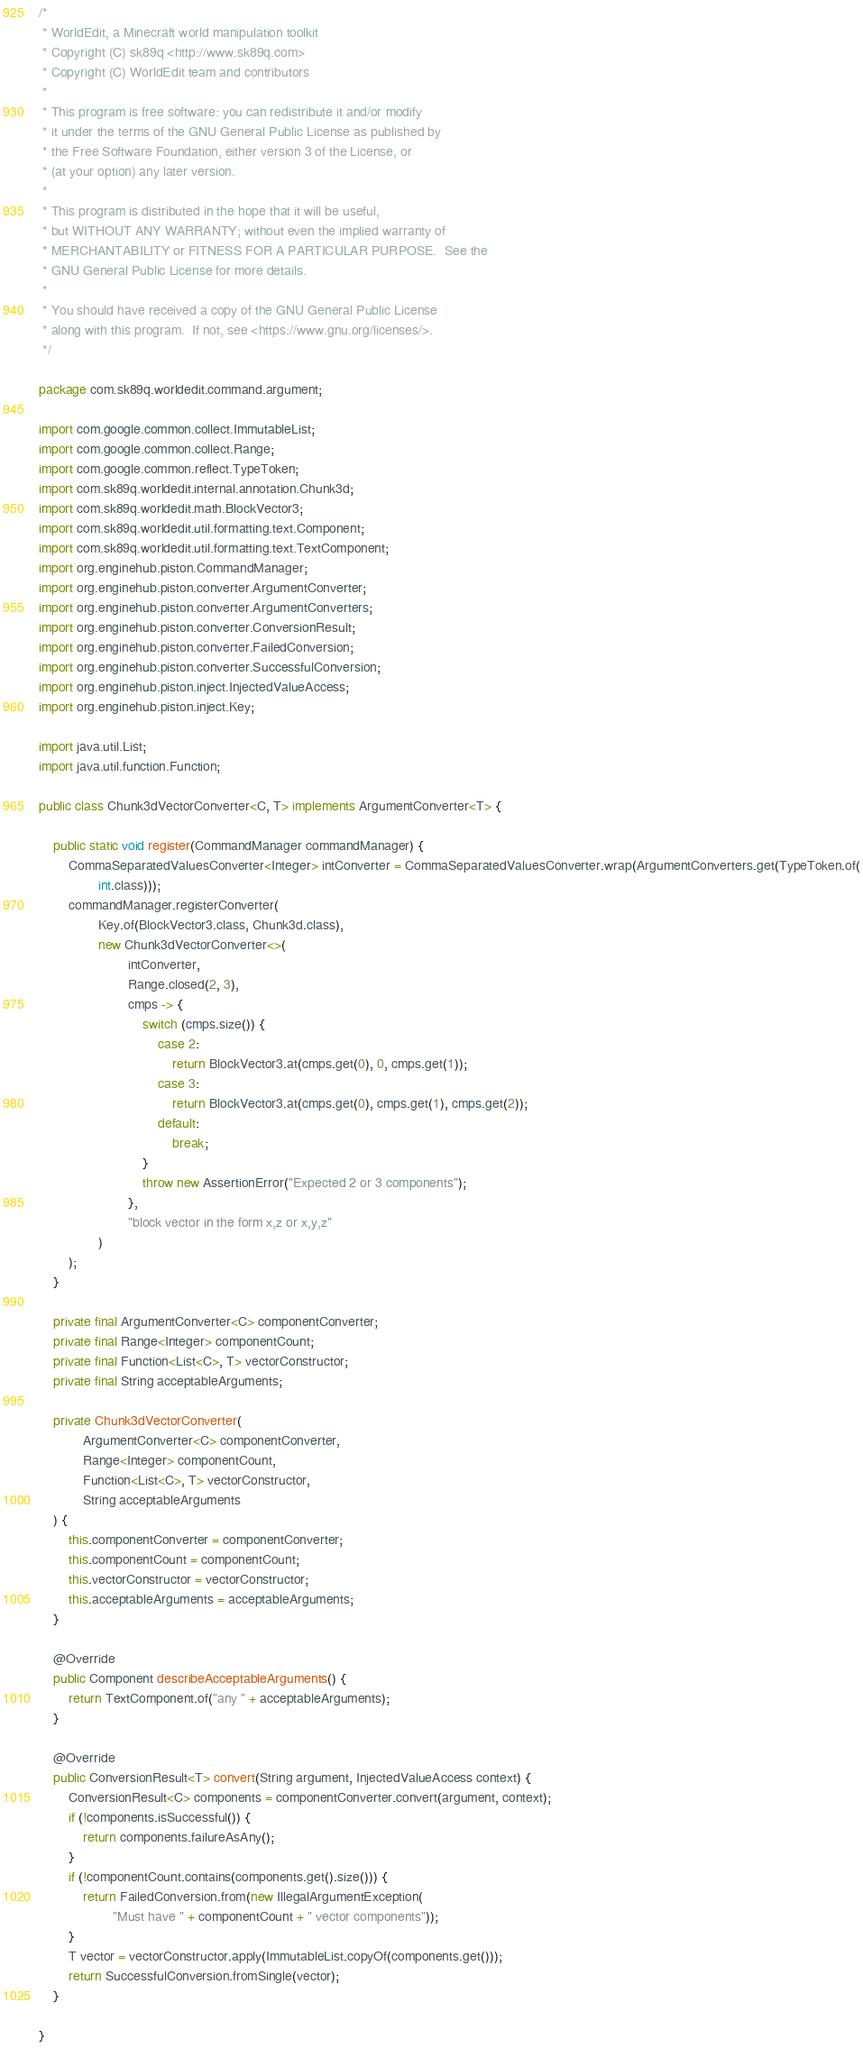Convert code to text. <code><loc_0><loc_0><loc_500><loc_500><_Java_>/*
 * WorldEdit, a Minecraft world manipulation toolkit
 * Copyright (C) sk89q <http://www.sk89q.com>
 * Copyright (C) WorldEdit team and contributors
 *
 * This program is free software: you can redistribute it and/or modify
 * it under the terms of the GNU General Public License as published by
 * the Free Software Foundation, either version 3 of the License, or
 * (at your option) any later version.
 *
 * This program is distributed in the hope that it will be useful,
 * but WITHOUT ANY WARRANTY; without even the implied warranty of
 * MERCHANTABILITY or FITNESS FOR A PARTICULAR PURPOSE.  See the
 * GNU General Public License for more details.
 *
 * You should have received a copy of the GNU General Public License
 * along with this program.  If not, see <https://www.gnu.org/licenses/>.
 */

package com.sk89q.worldedit.command.argument;

import com.google.common.collect.ImmutableList;
import com.google.common.collect.Range;
import com.google.common.reflect.TypeToken;
import com.sk89q.worldedit.internal.annotation.Chunk3d;
import com.sk89q.worldedit.math.BlockVector3;
import com.sk89q.worldedit.util.formatting.text.Component;
import com.sk89q.worldedit.util.formatting.text.TextComponent;
import org.enginehub.piston.CommandManager;
import org.enginehub.piston.converter.ArgumentConverter;
import org.enginehub.piston.converter.ArgumentConverters;
import org.enginehub.piston.converter.ConversionResult;
import org.enginehub.piston.converter.FailedConversion;
import org.enginehub.piston.converter.SuccessfulConversion;
import org.enginehub.piston.inject.InjectedValueAccess;
import org.enginehub.piston.inject.Key;

import java.util.List;
import java.util.function.Function;

public class Chunk3dVectorConverter<C, T> implements ArgumentConverter<T> {

    public static void register(CommandManager commandManager) {
        CommaSeparatedValuesConverter<Integer> intConverter = CommaSeparatedValuesConverter.wrap(ArgumentConverters.get(TypeToken.of(
                int.class)));
        commandManager.registerConverter(
                Key.of(BlockVector3.class, Chunk3d.class),
                new Chunk3dVectorConverter<>(
                        intConverter,
                        Range.closed(2, 3),
                        cmps -> {
                            switch (cmps.size()) {
                                case 2:
                                    return BlockVector3.at(cmps.get(0), 0, cmps.get(1));
                                case 3:
                                    return BlockVector3.at(cmps.get(0), cmps.get(1), cmps.get(2));
                                default:
                                    break;
                            }
                            throw new AssertionError("Expected 2 or 3 components");
                        },
                        "block vector in the form x,z or x,y,z"
                )
        );
    }

    private final ArgumentConverter<C> componentConverter;
    private final Range<Integer> componentCount;
    private final Function<List<C>, T> vectorConstructor;
    private final String acceptableArguments;

    private Chunk3dVectorConverter(
            ArgumentConverter<C> componentConverter,
            Range<Integer> componentCount,
            Function<List<C>, T> vectorConstructor,
            String acceptableArguments
    ) {
        this.componentConverter = componentConverter;
        this.componentCount = componentCount;
        this.vectorConstructor = vectorConstructor;
        this.acceptableArguments = acceptableArguments;
    }

    @Override
    public Component describeAcceptableArguments() {
        return TextComponent.of("any " + acceptableArguments);
    }

    @Override
    public ConversionResult<T> convert(String argument, InjectedValueAccess context) {
        ConversionResult<C> components = componentConverter.convert(argument, context);
        if (!components.isSuccessful()) {
            return components.failureAsAny();
        }
        if (!componentCount.contains(components.get().size())) {
            return FailedConversion.from(new IllegalArgumentException(
                    "Must have " + componentCount + " vector components"));
        }
        T vector = vectorConstructor.apply(ImmutableList.copyOf(components.get()));
        return SuccessfulConversion.fromSingle(vector);
    }

}
</code> 